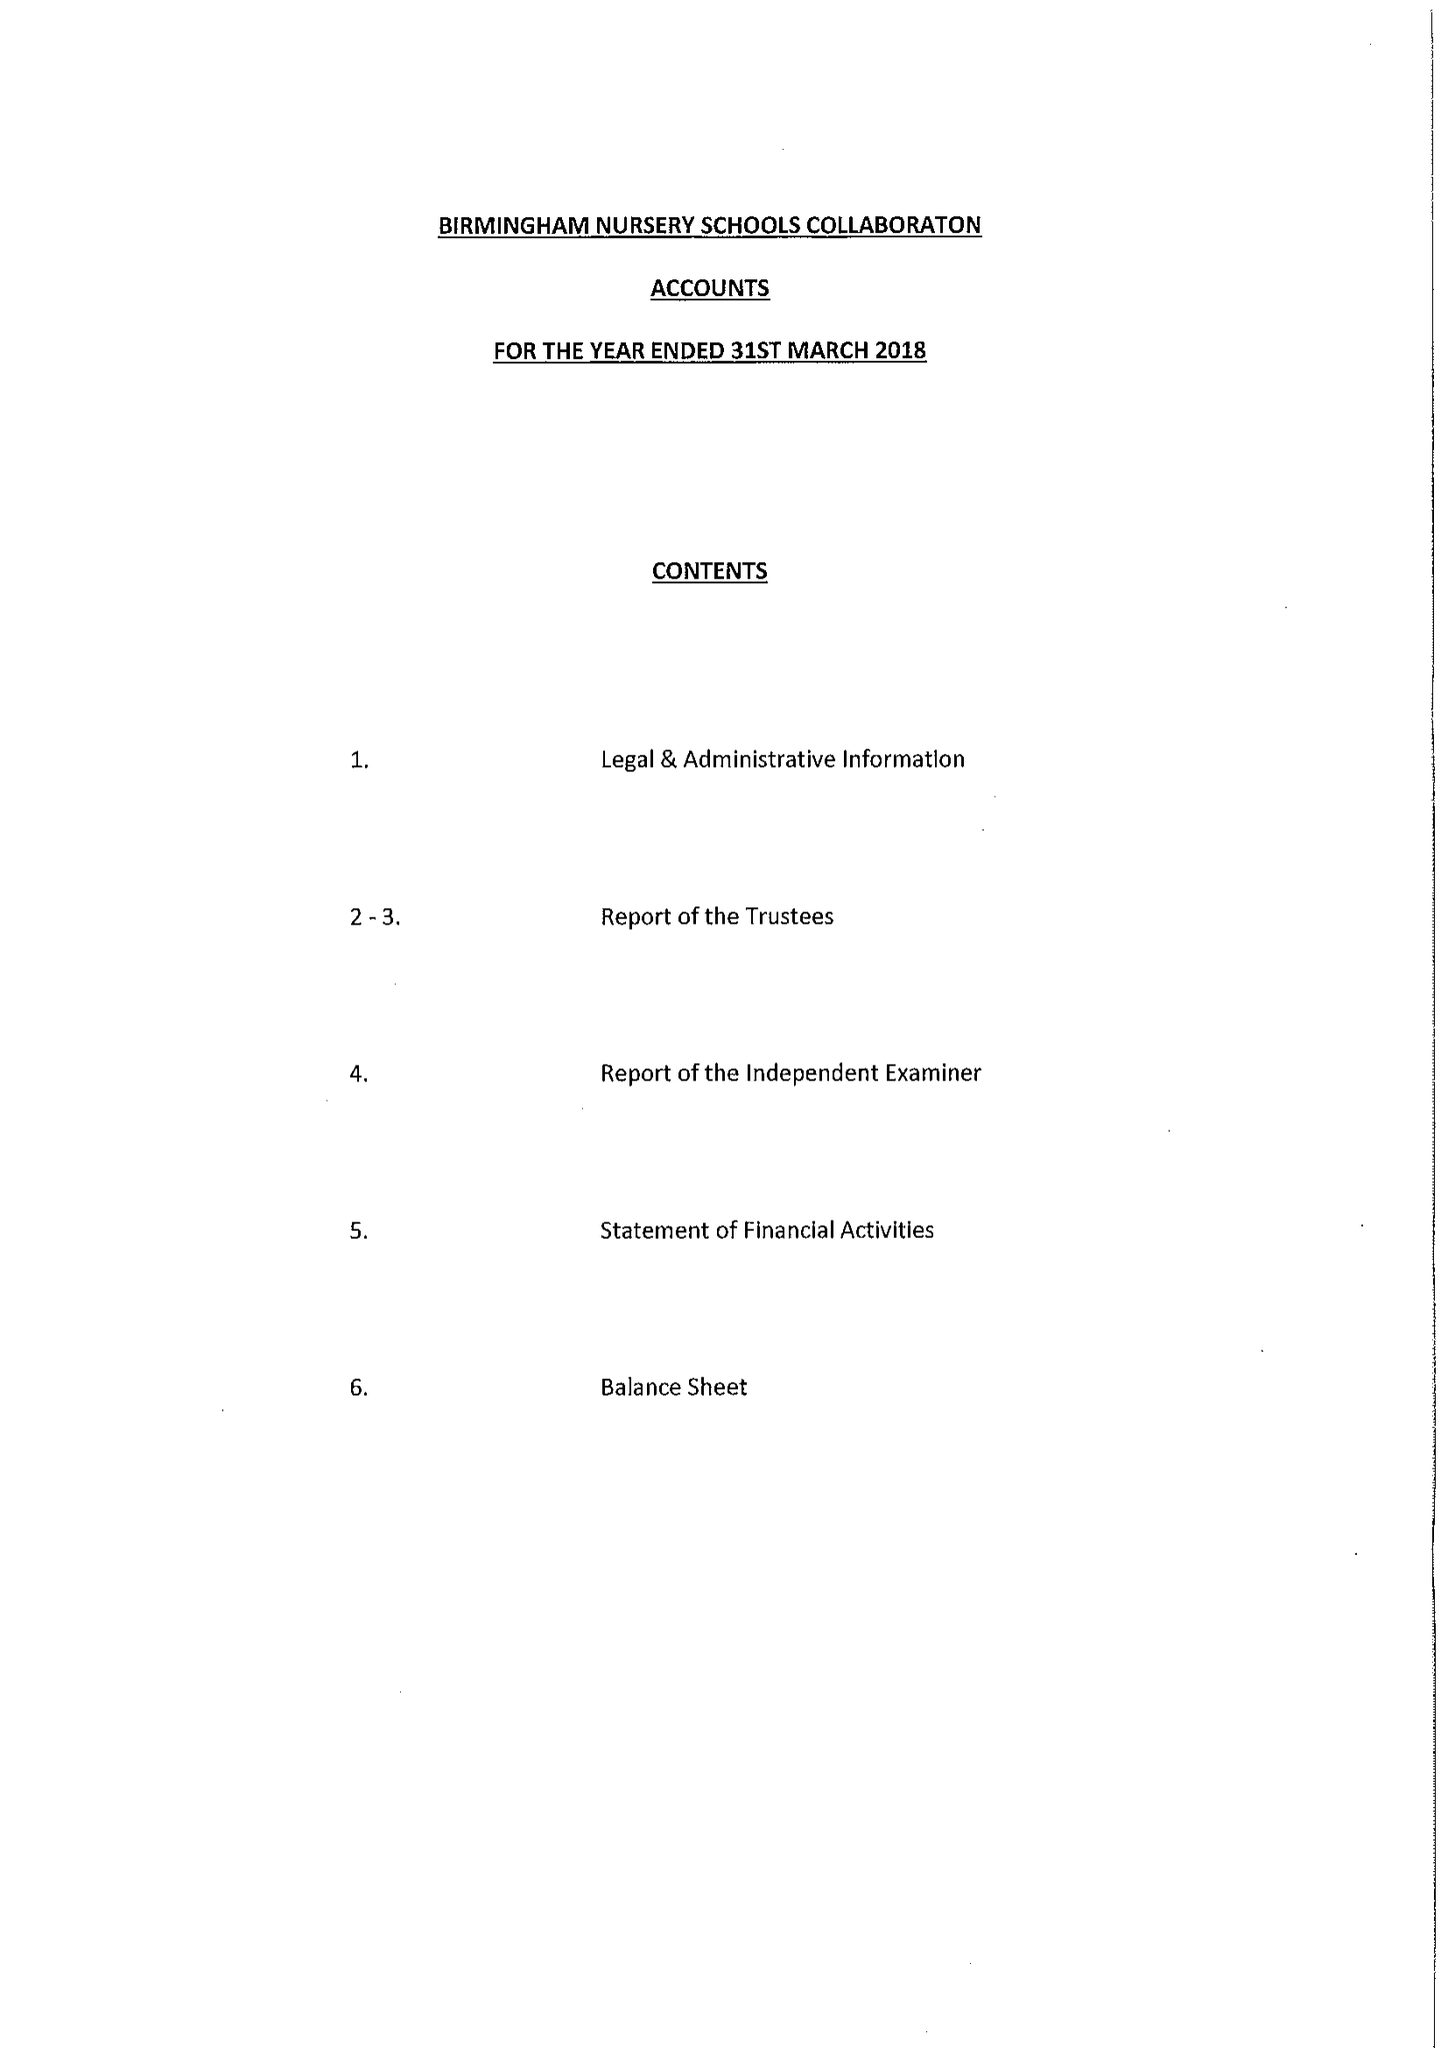What is the value for the address__postcode?
Answer the question using a single word or phrase. B33 8QB 